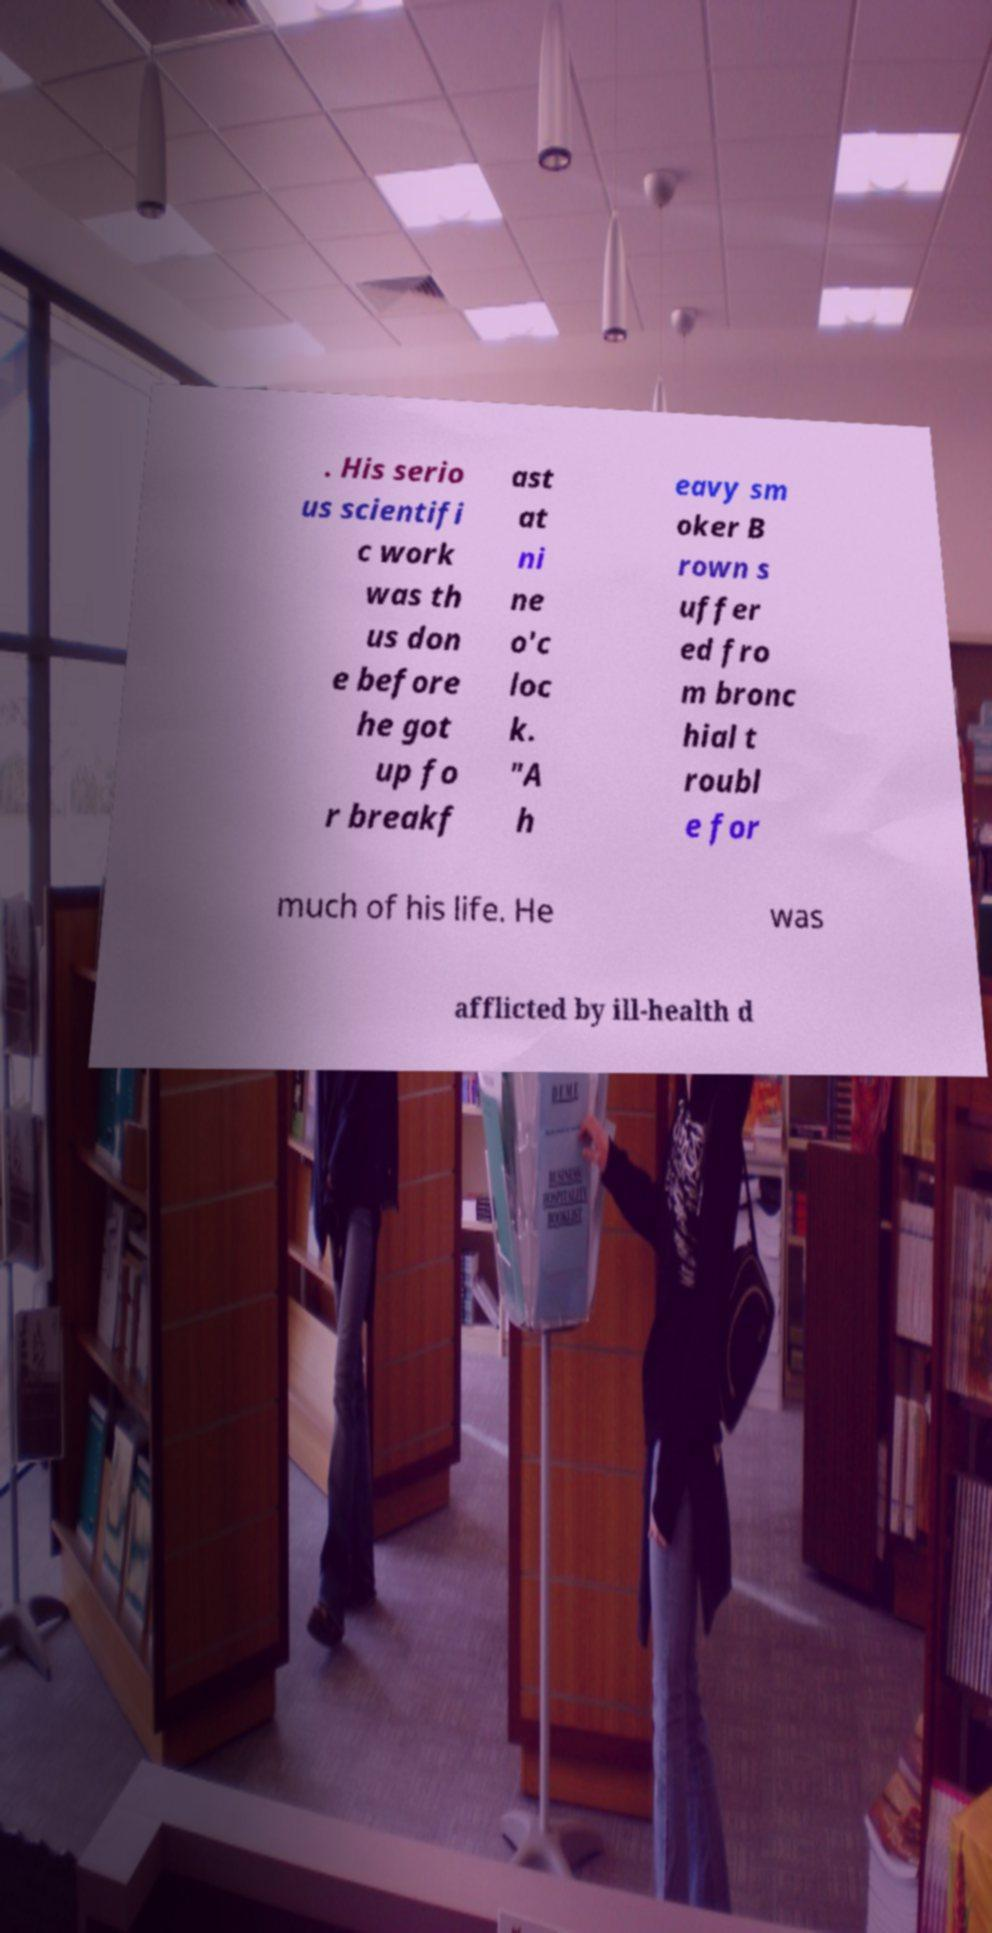For documentation purposes, I need the text within this image transcribed. Could you provide that? . His serio us scientifi c work was th us don e before he got up fo r breakf ast at ni ne o'c loc k. "A h eavy sm oker B rown s uffer ed fro m bronc hial t roubl e for much of his life. He was afflicted by ill-health d 